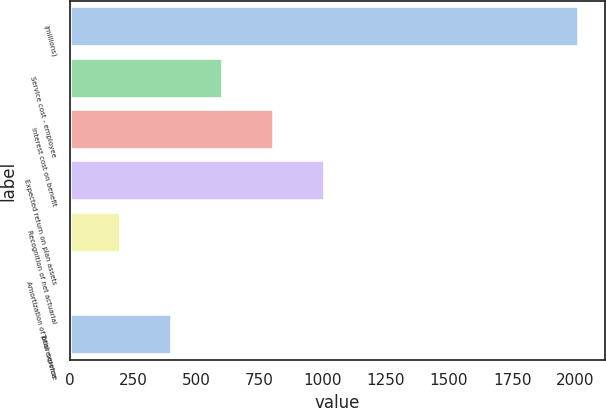<chart> <loc_0><loc_0><loc_500><loc_500><bar_chart><fcel>(millions)<fcel>Service cost - employee<fcel>Interest cost on benefit<fcel>Expected return on plan assets<fcel>Recognition of net actuarial<fcel>Amortization of prior service<fcel>Total expense<nl><fcel>2015<fcel>604.78<fcel>806.24<fcel>1007.7<fcel>201.86<fcel>0.4<fcel>403.32<nl></chart> 